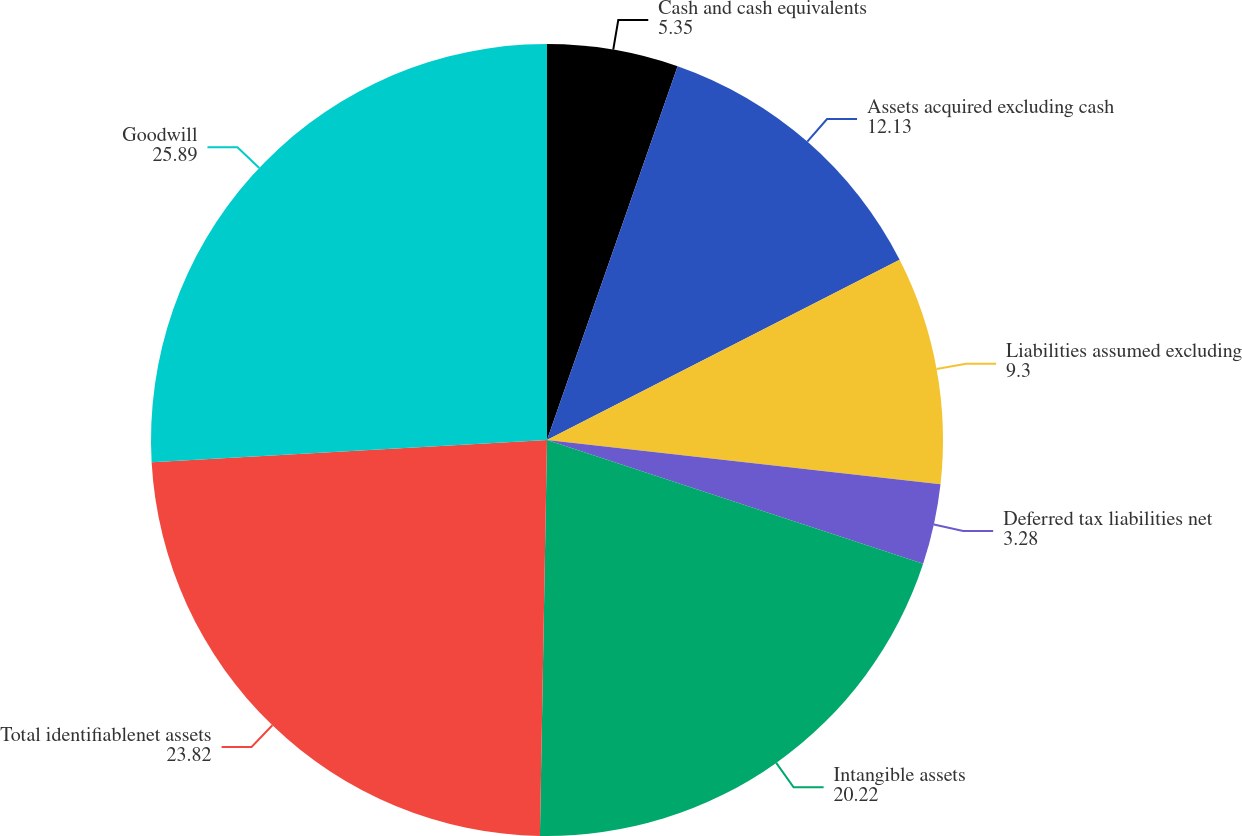<chart> <loc_0><loc_0><loc_500><loc_500><pie_chart><fcel>Cash and cash equivalents<fcel>Assets acquired excluding cash<fcel>Liabilities assumed excluding<fcel>Deferred tax liabilities net<fcel>Intangible assets<fcel>Total identifiablenet assets<fcel>Goodwill<nl><fcel>5.35%<fcel>12.13%<fcel>9.3%<fcel>3.28%<fcel>20.22%<fcel>23.82%<fcel>25.89%<nl></chart> 